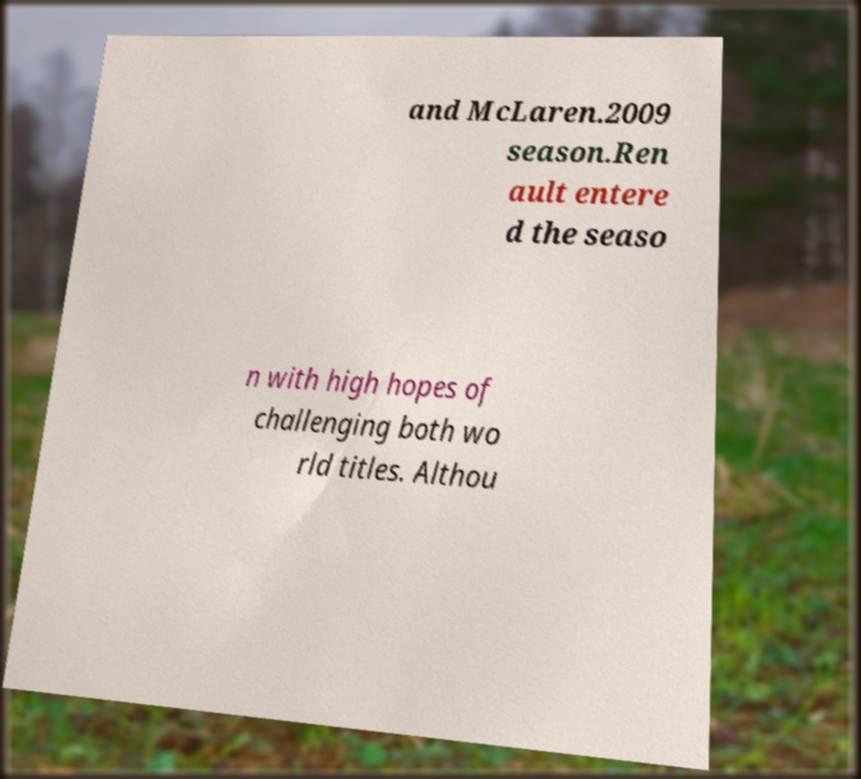I need the written content from this picture converted into text. Can you do that? and McLaren.2009 season.Ren ault entere d the seaso n with high hopes of challenging both wo rld titles. Althou 